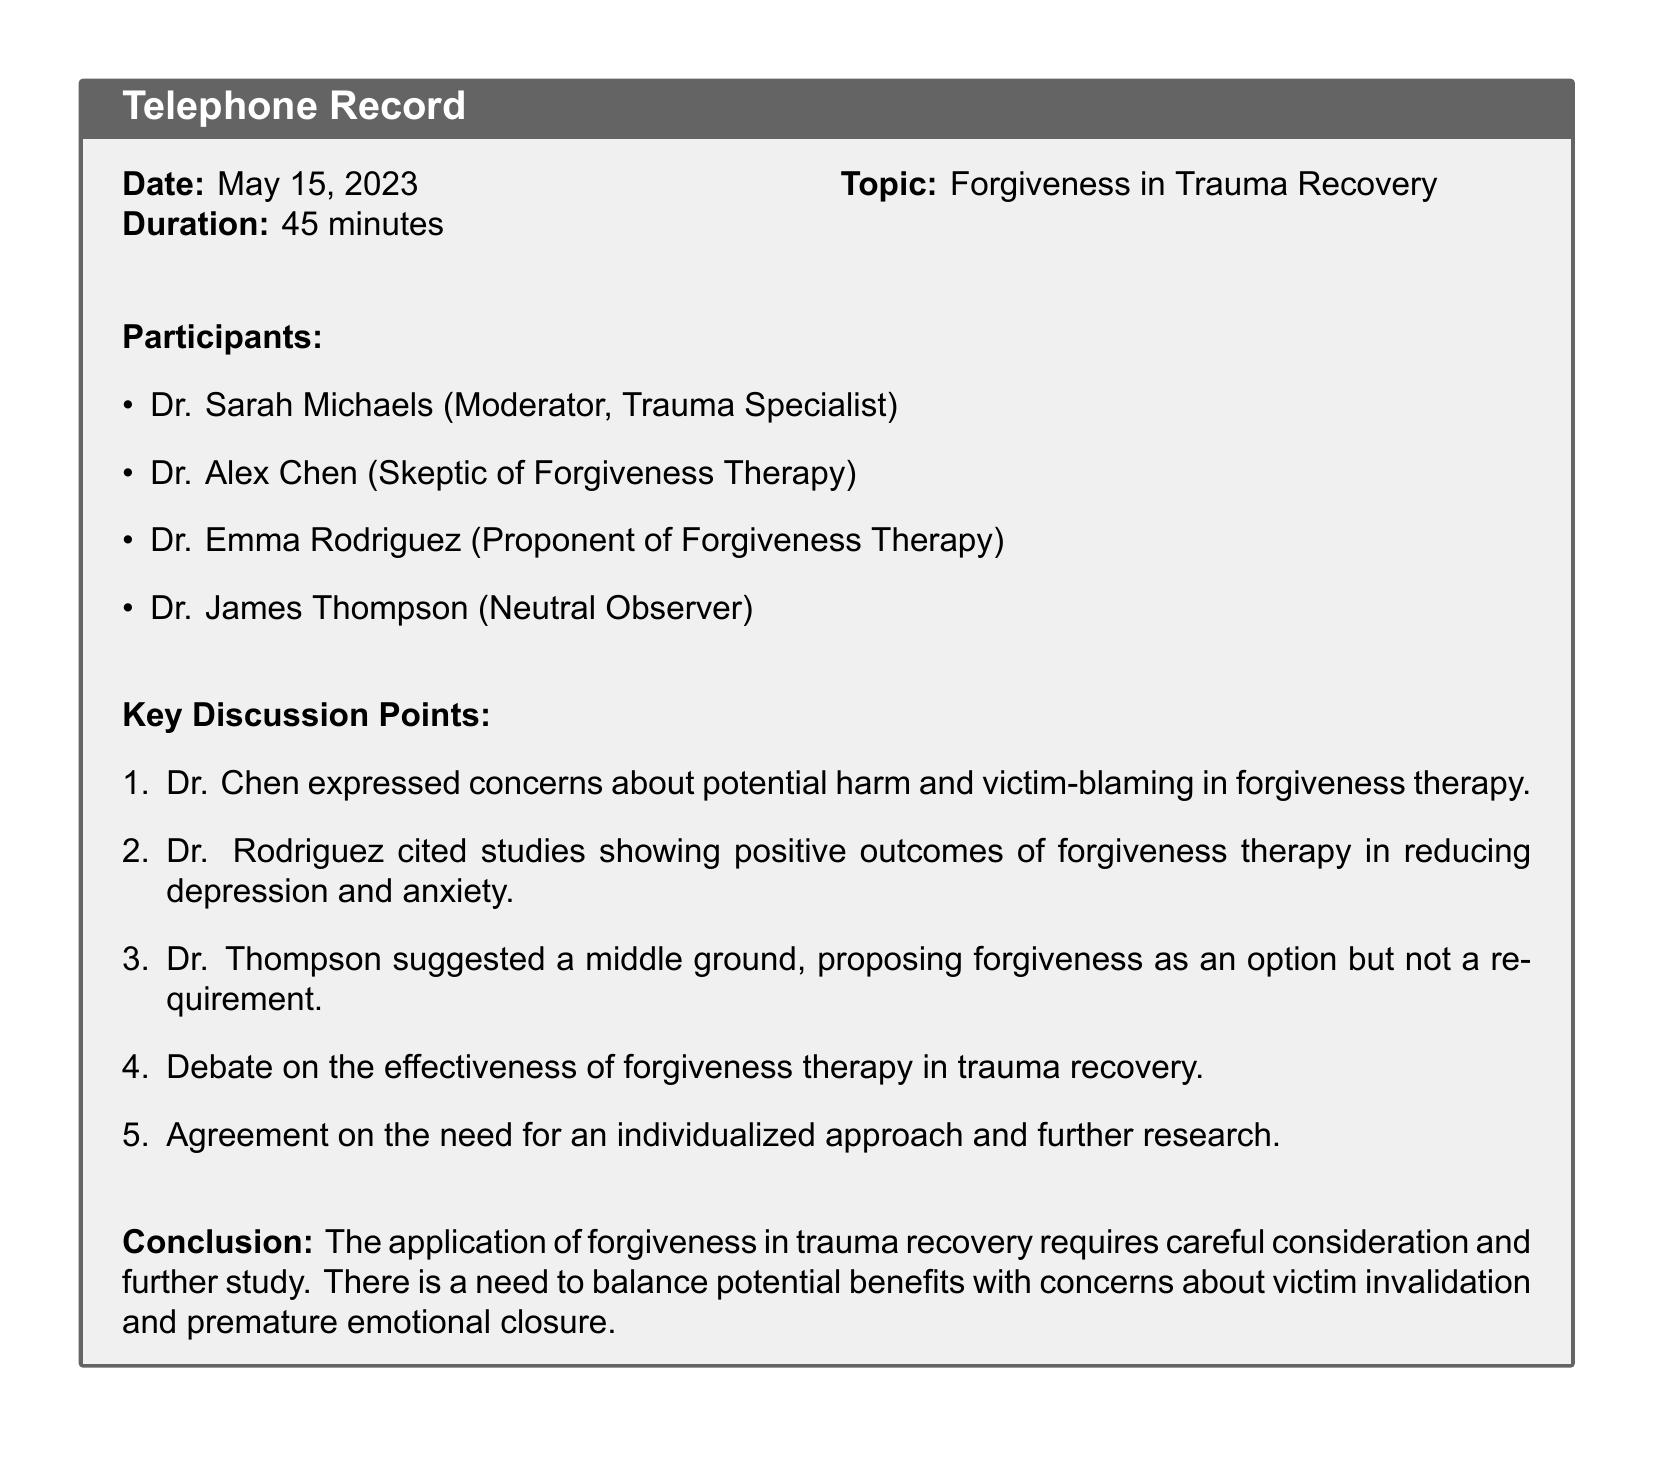What was the date of the conference call? The date of the conference call is explicitly stated in the document as May 15, 2023.
Answer: May 15, 2023 Who was the moderator of the call? The document specifies that Dr. Sarah Michaels served as the moderator of the call.
Answer: Dr. Sarah Michaels What was the duration of the call? The call duration is indicated in the document as lasting 45 minutes.
Answer: 45 minutes Which participant expressed concerns about forgiveness therapy? The document notes that Dr. Alex Chen expressed concerns about potential harm and victim-blaming in forgiveness therapy.
Answer: Dr. Alex Chen What approach did Dr. Thompson propose regarding forgiveness? Dr. Thompson suggested a middle ground regarding forgiveness in that it should be viewed as an option but not a requirement.
Answer: Forgiveness as an option What was one of the benefits cited for forgiveness therapy? Dr. Rodriguez cited studies showing that forgiveness therapy can lead to reduced depression and anxiety.
Answer: Reduced depression and anxiety Is there agreement on the need for further research? The document mentions that there is an agreement among participants on the need for individualized approaches and further research.
Answer: Yes What is a key concern about forgiveness therapy mentioned in the discussion? The document highlights concerns about victim invalidation and premature emotional closure as key issues regarding forgiveness therapy.
Answer: Victim invalidation What kind of document is this? Given the structure and content, this document is a record of a telephone conference call among professionals discussing a specific topic related to psychology.
Answer: Telephone conference call record 